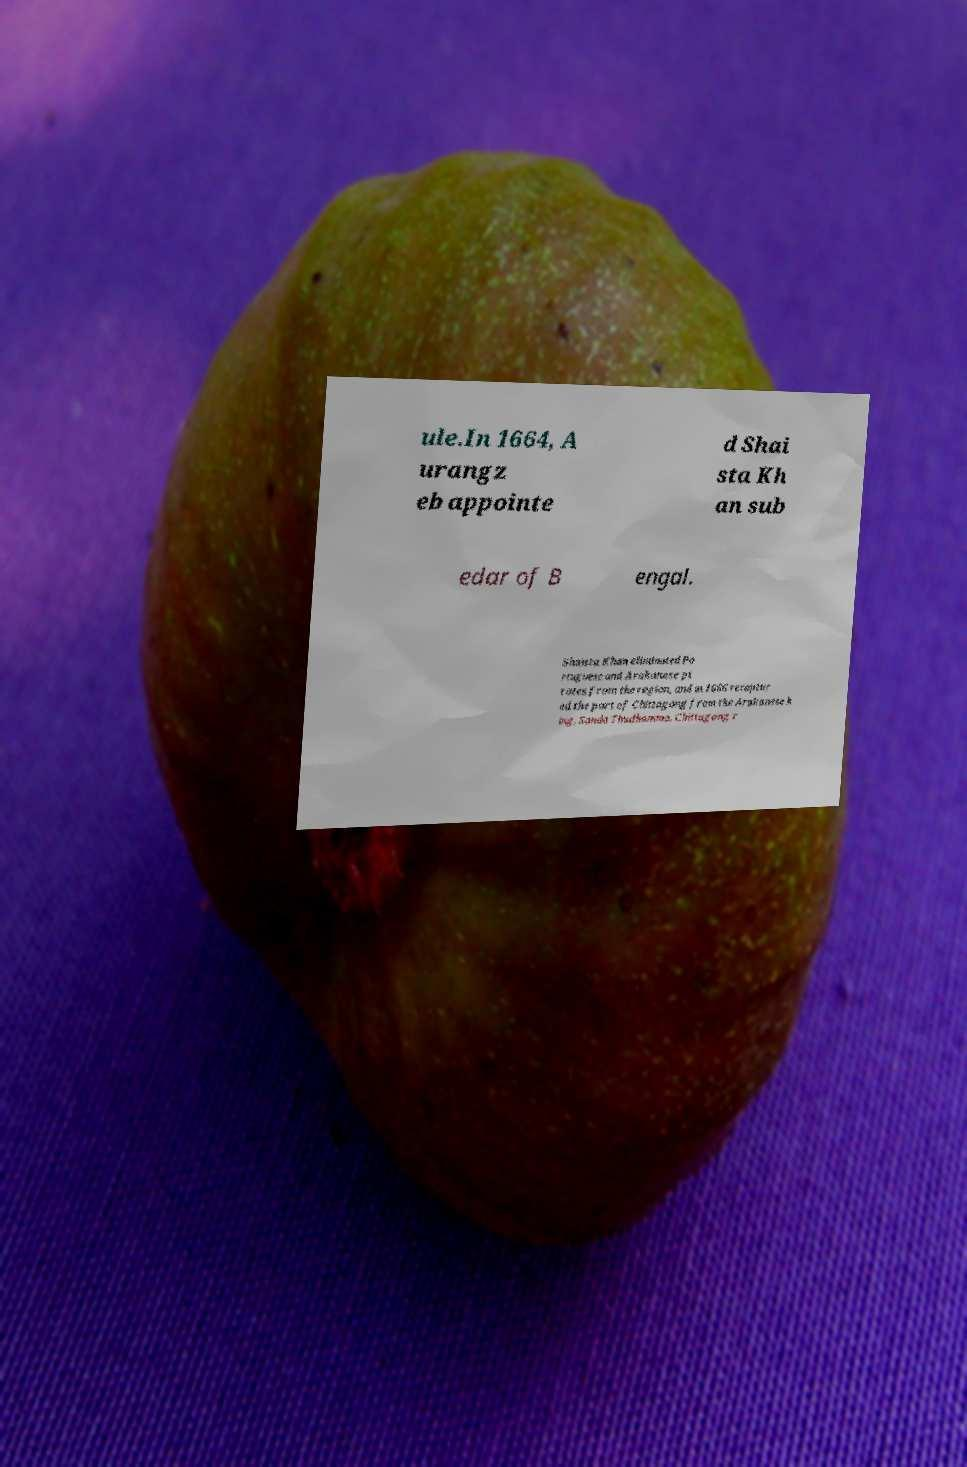There's text embedded in this image that I need extracted. Can you transcribe it verbatim? ule.In 1664, A urangz eb appointe d Shai sta Kh an sub edar of B engal. Shaista Khan eliminated Po rtuguese and Arakanese pi rates from the region, and in 1666 recaptur ed the port of Chittagong from the Arakanese k ing, Sanda Thudhamma. Chittagong r 